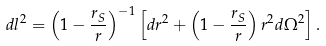<formula> <loc_0><loc_0><loc_500><loc_500>d l ^ { 2 } = \left ( 1 - \frac { r _ { S } } { r } \right ) ^ { - 1 } \left [ d r ^ { 2 } + \left ( 1 - \frac { r _ { S } } { r } \right ) r ^ { 2 } d \Omega ^ { 2 } \right ] .</formula> 